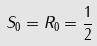<formula> <loc_0><loc_0><loc_500><loc_500>S _ { 0 } = R _ { 0 } = \frac { 1 } { 2 }</formula> 